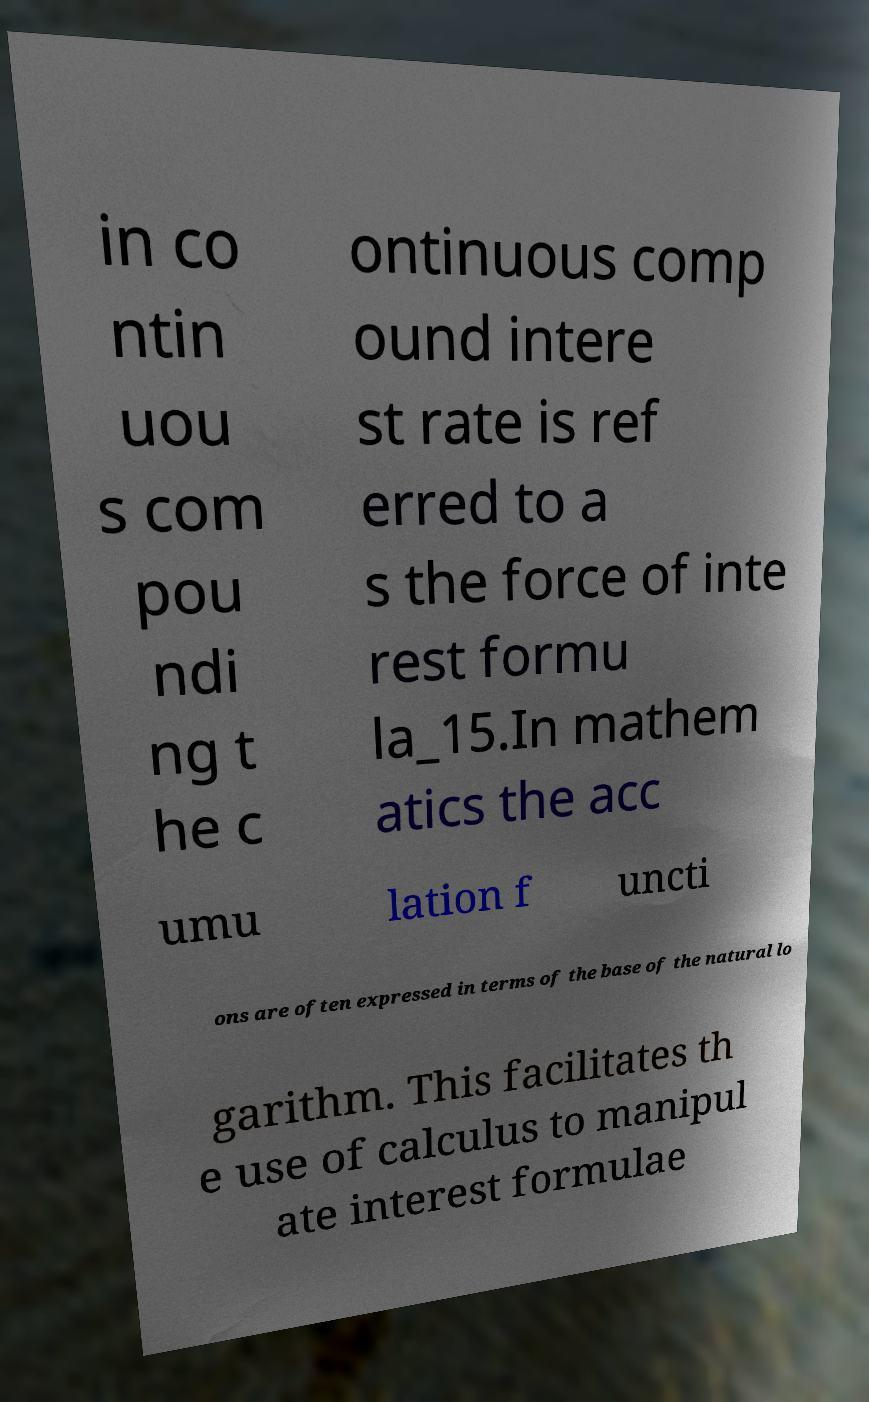Can you accurately transcribe the text from the provided image for me? in co ntin uou s com pou ndi ng t he c ontinuous comp ound intere st rate is ref erred to a s the force of inte rest formu la_15.In mathem atics the acc umu lation f uncti ons are often expressed in terms of the base of the natural lo garithm. This facilitates th e use of calculus to manipul ate interest formulae 